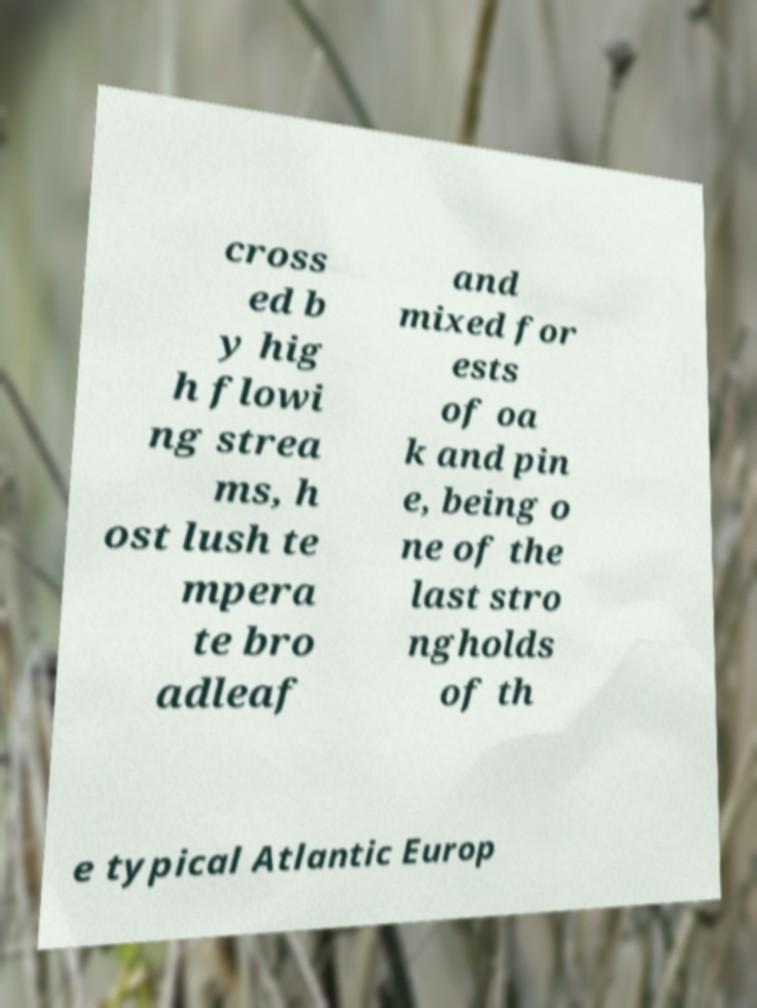Can you accurately transcribe the text from the provided image for me? cross ed b y hig h flowi ng strea ms, h ost lush te mpera te bro adleaf and mixed for ests of oa k and pin e, being o ne of the last stro ngholds of th e typical Atlantic Europ 